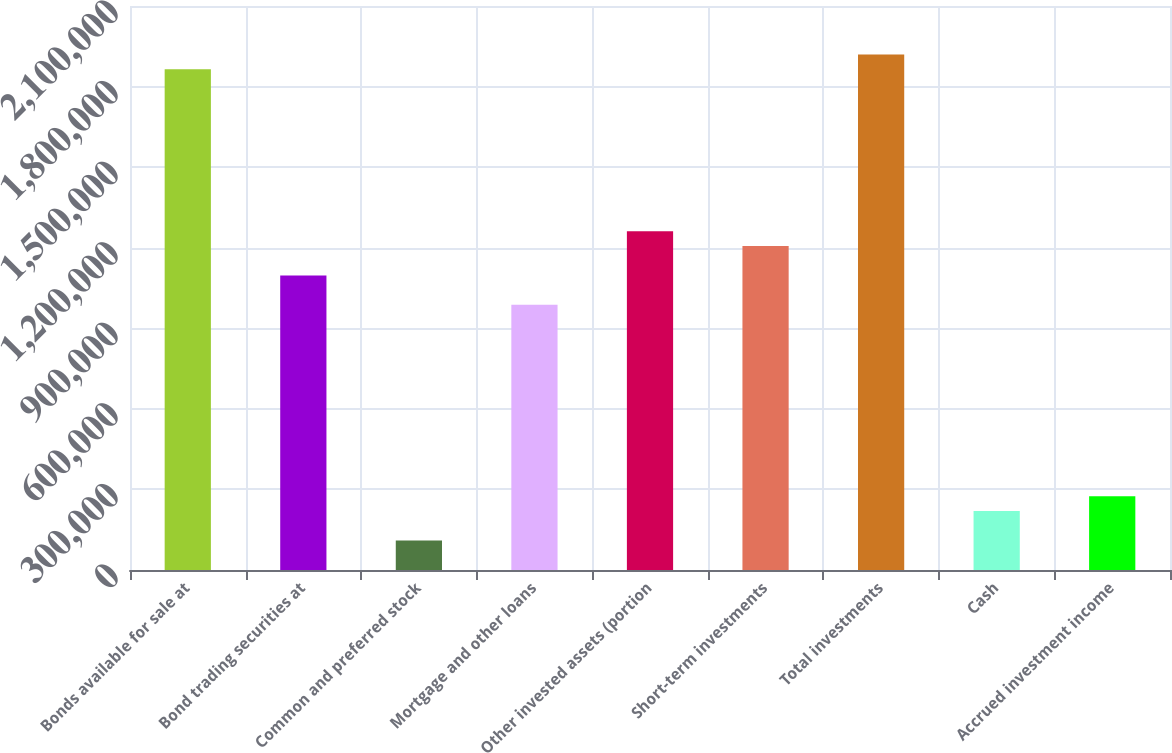Convert chart to OTSL. <chart><loc_0><loc_0><loc_500><loc_500><bar_chart><fcel>Bonds available for sale at<fcel>Bond trading securities at<fcel>Common and preferred stock<fcel>Mortgage and other loans<fcel>Other invested assets (portion<fcel>Short-term investments<fcel>Total investments<fcel>Cash<fcel>Accrued investment income<nl><fcel>1.86455e+06<fcel>1.09693e+06<fcel>109994<fcel>987272<fcel>1.26142e+06<fcel>1.20659e+06<fcel>1.91938e+06<fcel>219654<fcel>274484<nl></chart> 